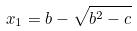Convert formula to latex. <formula><loc_0><loc_0><loc_500><loc_500>x _ { 1 } = b - \sqrt { b ^ { 2 } - c }</formula> 